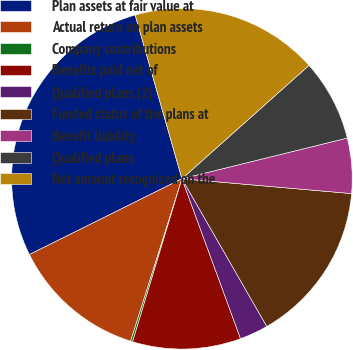Convert chart to OTSL. <chart><loc_0><loc_0><loc_500><loc_500><pie_chart><fcel>Plan assets at fair value at<fcel>Actual return on plan assets<fcel>Company contributions<fcel>Benefits paid net of<fcel>Qualified plans (2)<fcel>Funded status of the plans at<fcel>Benefit liability<fcel>Qualified plans<fcel>Net amount recognized on the<nl><fcel>27.91%<fcel>12.79%<fcel>0.19%<fcel>10.27%<fcel>2.71%<fcel>15.31%<fcel>5.23%<fcel>7.75%<fcel>17.83%<nl></chart> 